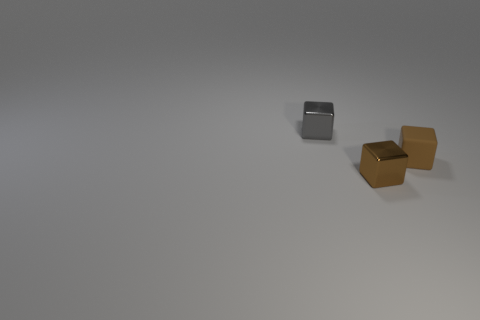There is a thing that is in front of the small rubber block in front of the gray shiny block; what is its size?
Your answer should be compact. Small. There is a tiny object on the right side of the tiny brown metal cube; does it have the same color as the block in front of the tiny brown rubber cube?
Offer a very short reply. Yes. There is a small brown thing on the right side of the brown object that is to the left of the matte cube; how many brown rubber blocks are left of it?
Keep it short and to the point. 0. What number of small objects are both in front of the small brown rubber object and on the right side of the brown shiny cube?
Provide a short and direct response. 0. Are there more tiny gray shiny cubes that are to the right of the gray metallic cube than brown shiny objects?
Ensure brevity in your answer.  No. How many brown rubber objects are the same size as the brown rubber cube?
Offer a terse response. 0. What size is the metallic thing that is the same color as the tiny matte block?
Provide a succinct answer. Small. How many tiny things are either rubber cubes or brown things?
Offer a very short reply. 2. What number of cubes are there?
Your response must be concise. 3. Is the number of metal objects in front of the brown shiny block the same as the number of brown matte cubes that are to the left of the tiny rubber block?
Give a very brief answer. Yes. 